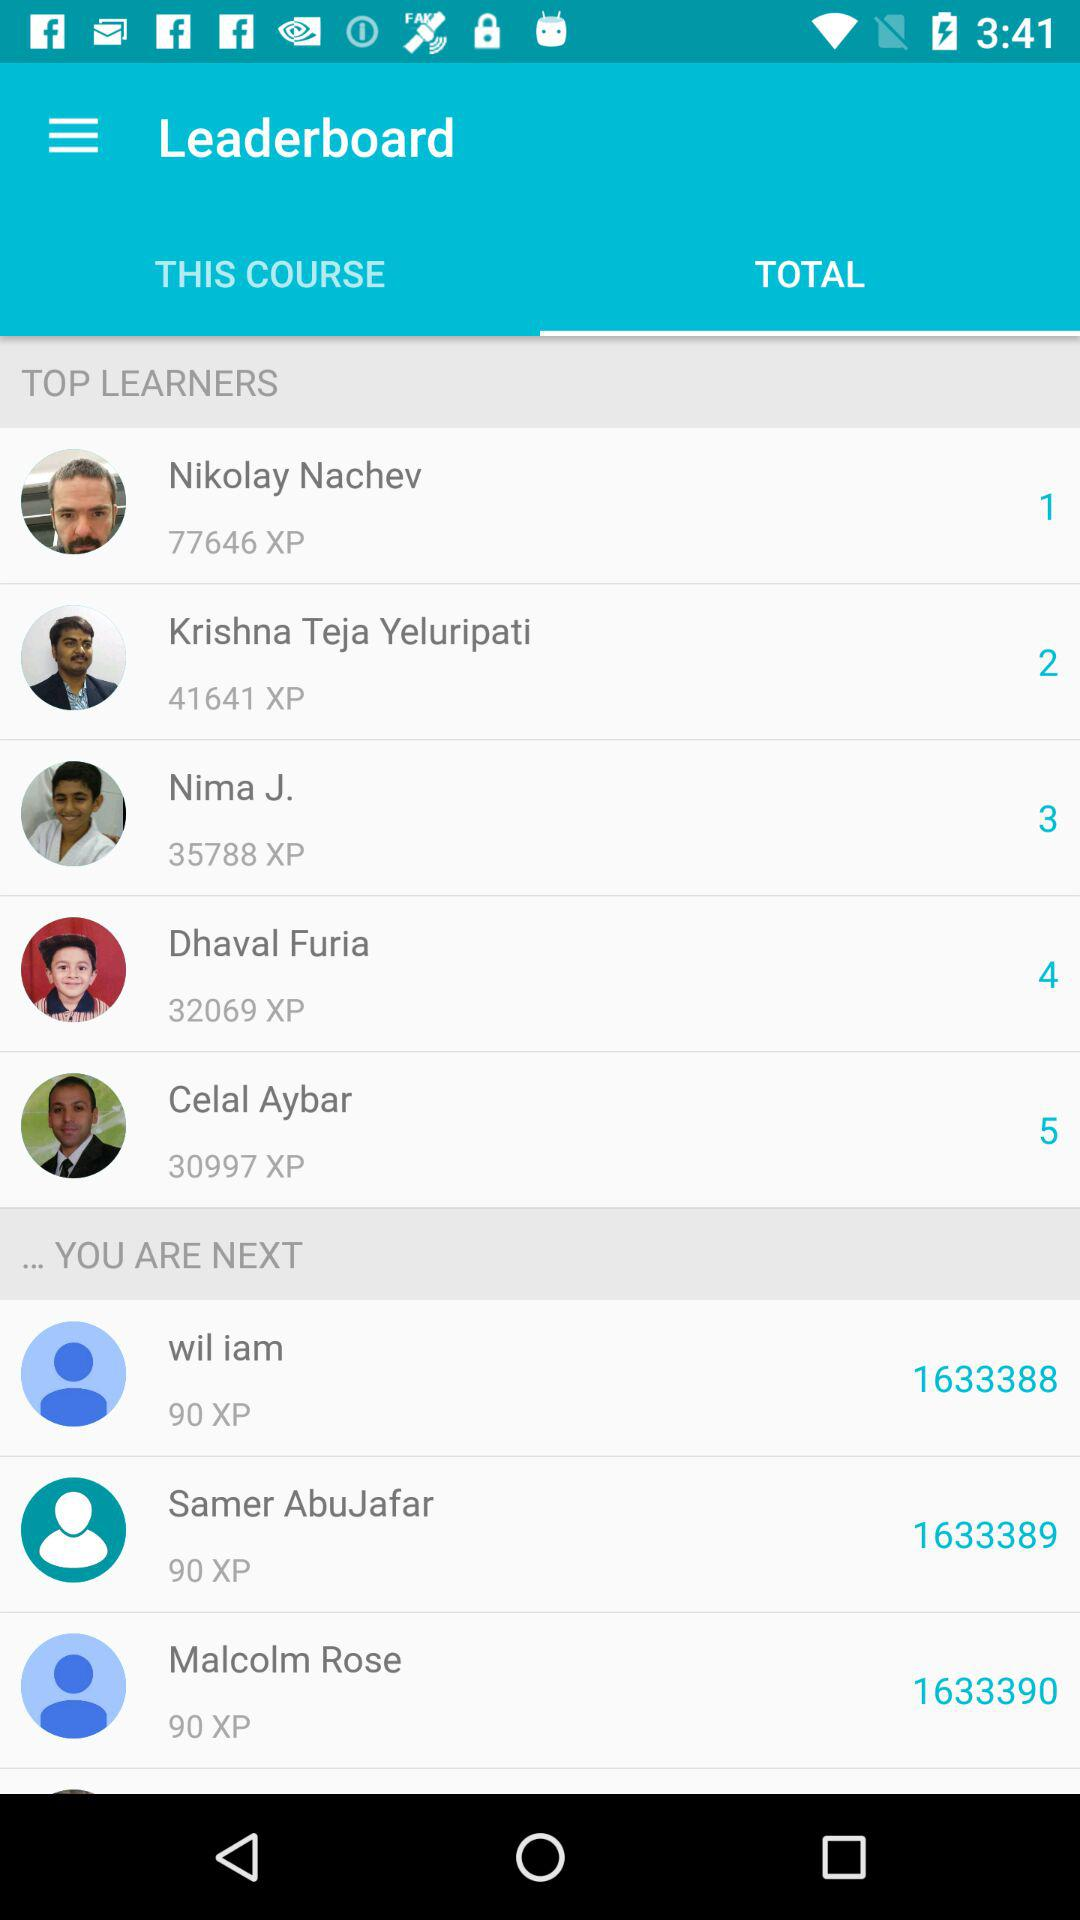What is the rank of Celal Aybar? The rank of Celal Aybar is 5. 